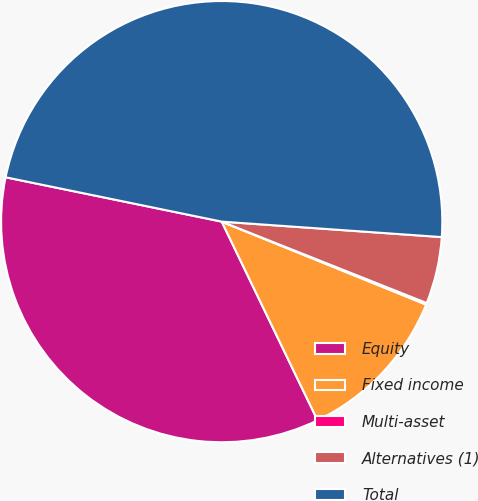Convert chart to OTSL. <chart><loc_0><loc_0><loc_500><loc_500><pie_chart><fcel>Equity<fcel>Fixed income<fcel>Multi-asset<fcel>Alternatives (1)<fcel>Total<nl><fcel>35.38%<fcel>11.71%<fcel>0.12%<fcel>4.9%<fcel>47.9%<nl></chart> 